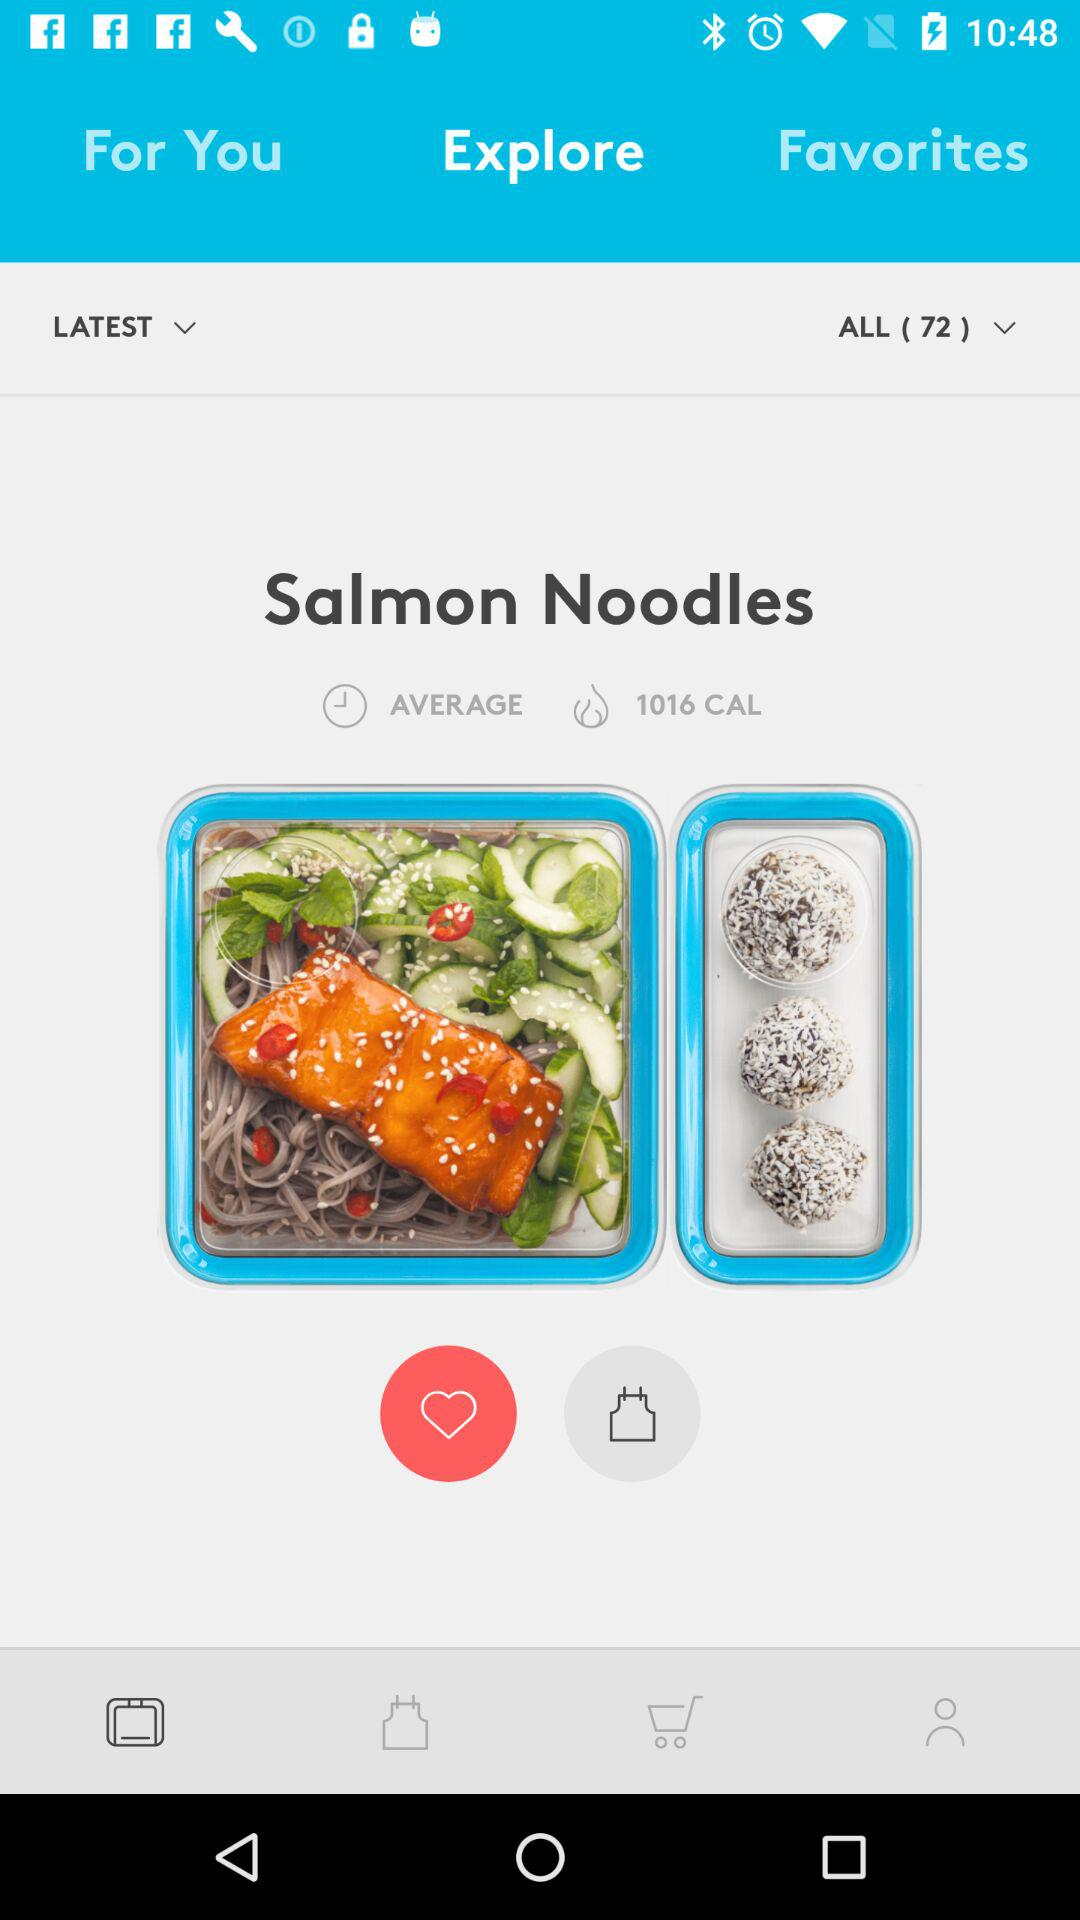How many calories does the Salmon Noodles recipe have?
Answer the question using a single word or phrase. 1016 